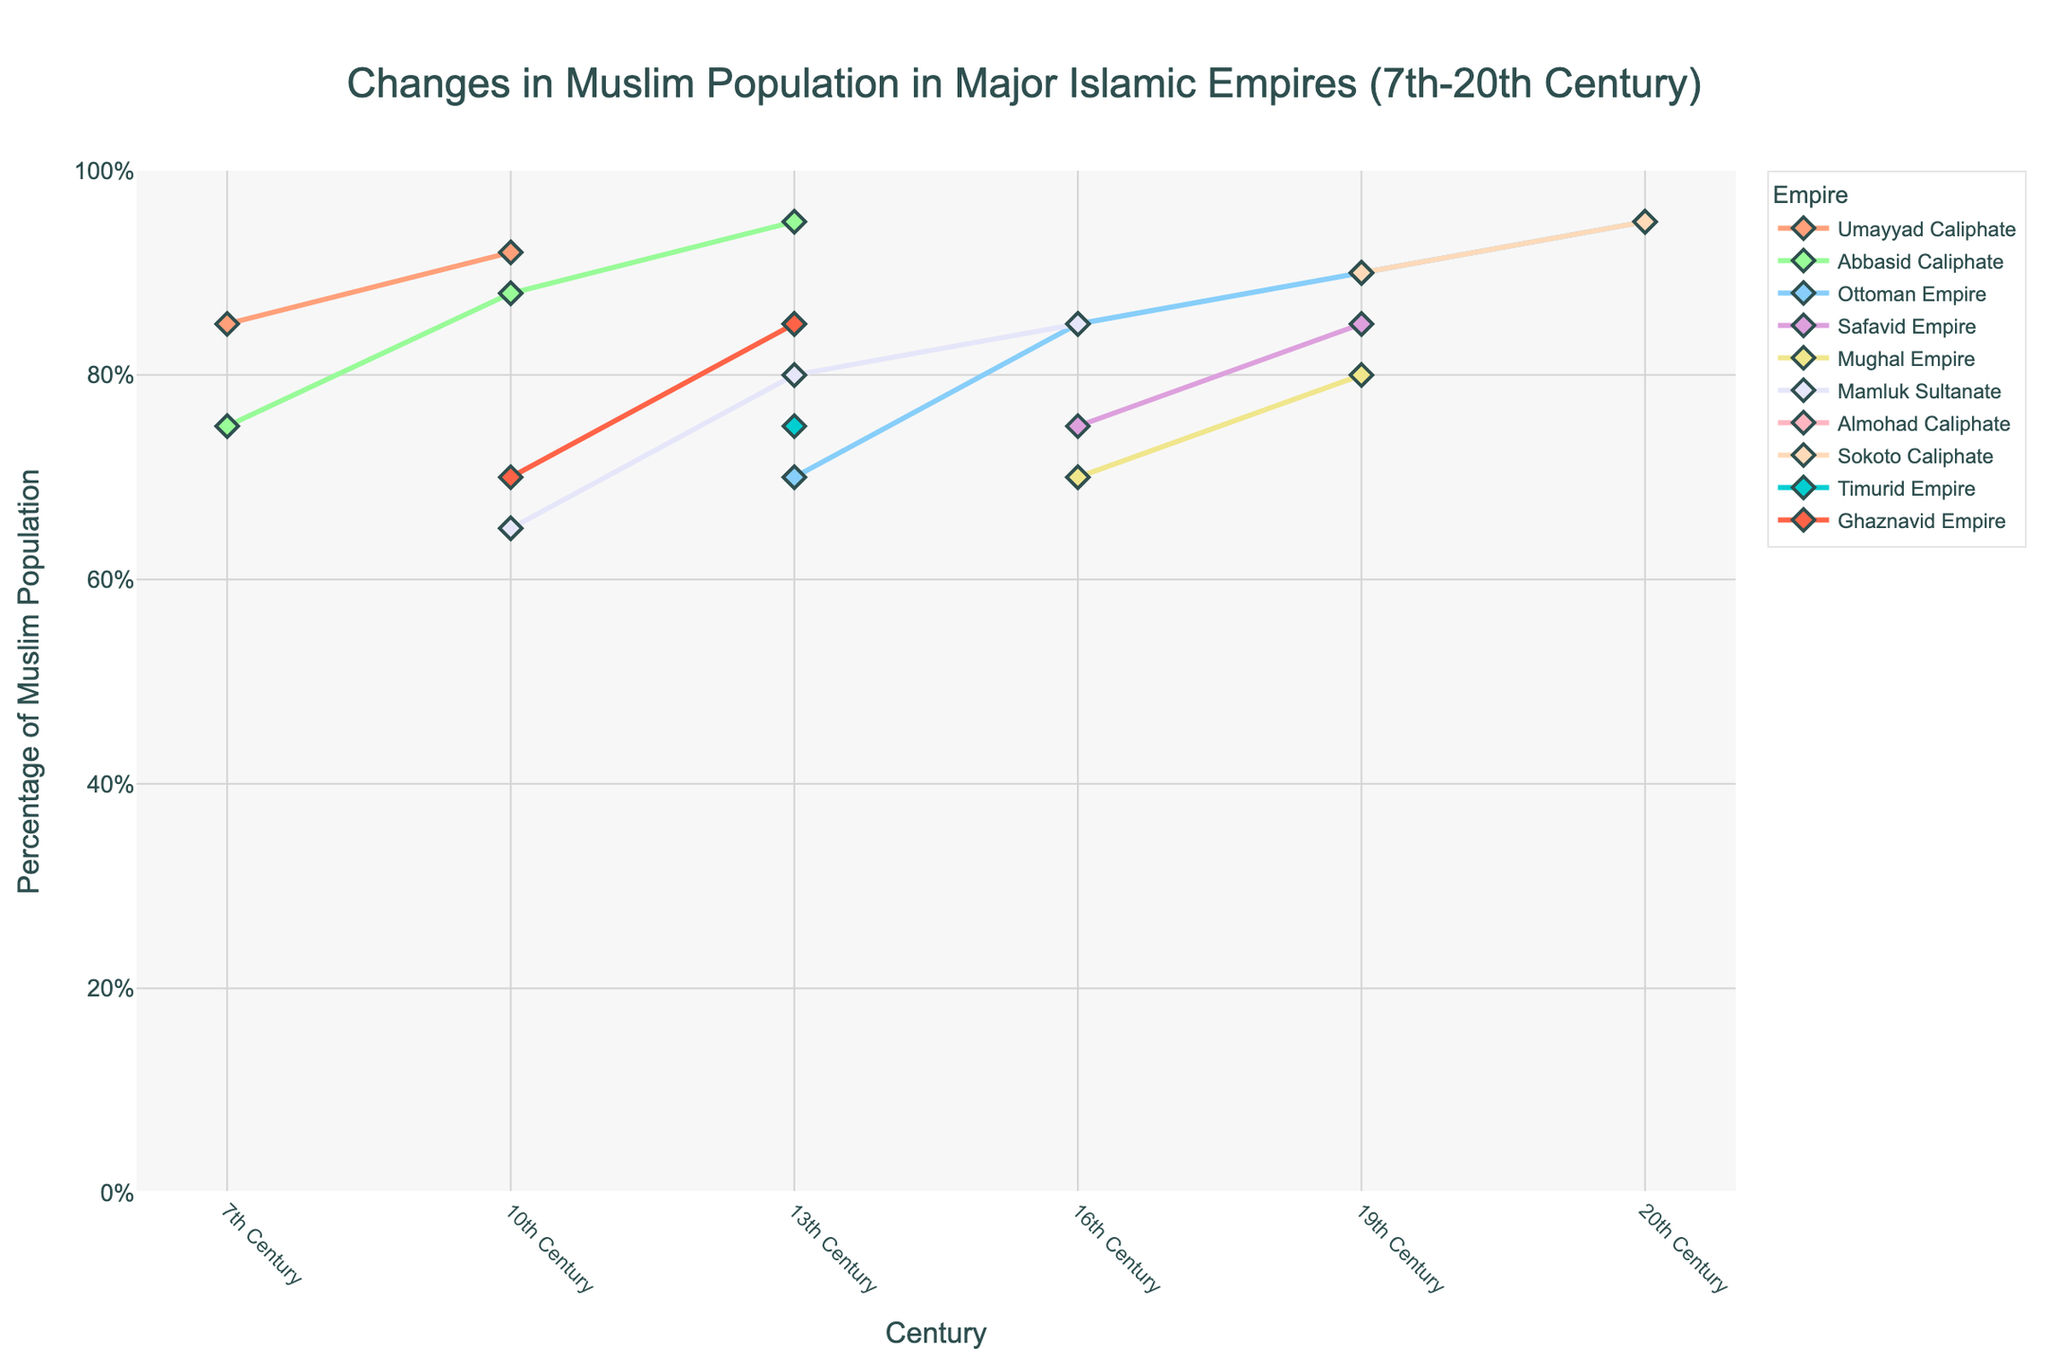Which empire had the highest percentage of Muslim population in the 7th century? By observing the plot, we see that the Umayyad Caliphate is the only empire with data in the 7th century, showing a percentage of 85%.
Answer: Umayyad Caliphate In which century did the Abbasid Caliphate reach its peak Muslim population percentage? The peak for the Abbasid Caliphate is depicted at the highest point on its line, which occurs in the 13th century with a percentage of 95%.
Answer: 13th Century Which two empires had a Muslim population percentage of 85% in the 16th century? By examining the lines in the 16th century, we see that both the Ottoman Empire and the Mamluk Sultanate have data points at 85%.
Answer: Ottoman Empire, Mamluk Sultanate Compare the average Muslim population percentage of the Safavid Empire and Mughal Empire. Which empire had the higher average? Calculate average population percentage for each: Safavid Empire (75 + 85)/2 = 80, Mughal Empire (70 + 80)/2 = 75. Therefore, the Safavid Empire has a higher average.
Answer: Safavid Empire When did the Umayyad Caliphate cease to exist, and which empire saw a rise in the Muslim population percentage around that time? The Umayyad Caliphate data drops to 0 after 10th century, and the Abbasid Caliphate shows a rise during that period, reaching 95% in the 13th century.
Answer: 10th Century, Abbasid Caliphate Which empire experienced the largest increase in the Muslim population percentage from its first recorded century to its peak? Calculate differences: Umayyad (7), Abbasid (20), Ottoman (25), Safavid (10), Mughal (10), Mamluk (20), Almohad (85), Sokoto (95), Timurid (75), Ghaznavid (15). The Sokoto Caliphate's increase from 0 to 95% is the largest.
Answer: Sokoto Caliphate Did any empire show a decrease in the Muslim population percentage over time in the provided data? Examine each empire's trend lines for decreasing patterns. The Mamluk Sultanate shows a decrease from 85% in 16th century to 0% in 19th century.
Answer: Mamluk Sultanate Which century has the highest concentration of Muslim empires with a population percentage above 70%? Examining the plot, the 16th century shows multiple empires: Ottoman, Safavid, Mughal, and Mamluk—with percentages above 70%.
Answer: 16th Century What is the sum of the peak Muslim population percentages of all empires? Sum all peak percentages: Umayyad (92), Abbasid (95), Ottoman (95), Safavid (85), Mughal (80), Mamluk (85), Almohad (85), Sokoto (95), Timurid (75), Ghaznavid (85). Total = 786.
Answer: 786 